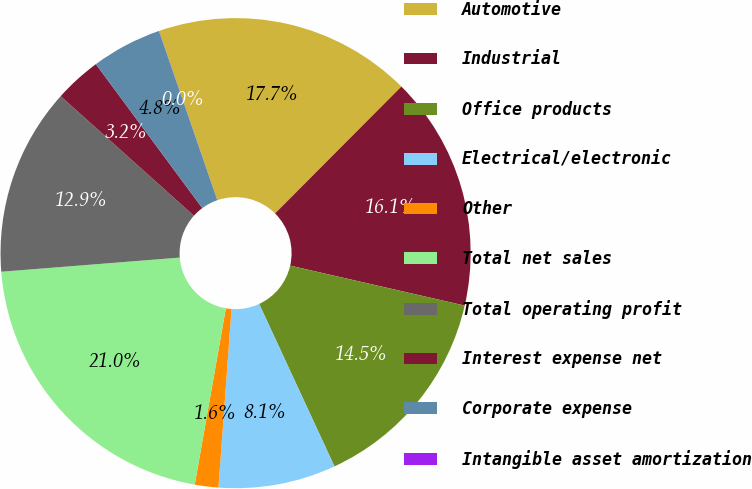<chart> <loc_0><loc_0><loc_500><loc_500><pie_chart><fcel>Automotive<fcel>Industrial<fcel>Office products<fcel>Electrical/electronic<fcel>Other<fcel>Total net sales<fcel>Total operating profit<fcel>Interest expense net<fcel>Corporate expense<fcel>Intangible asset amortization<nl><fcel>17.74%<fcel>16.12%<fcel>14.51%<fcel>8.07%<fcel>1.62%<fcel>20.96%<fcel>12.9%<fcel>3.23%<fcel>4.84%<fcel>0.01%<nl></chart> 